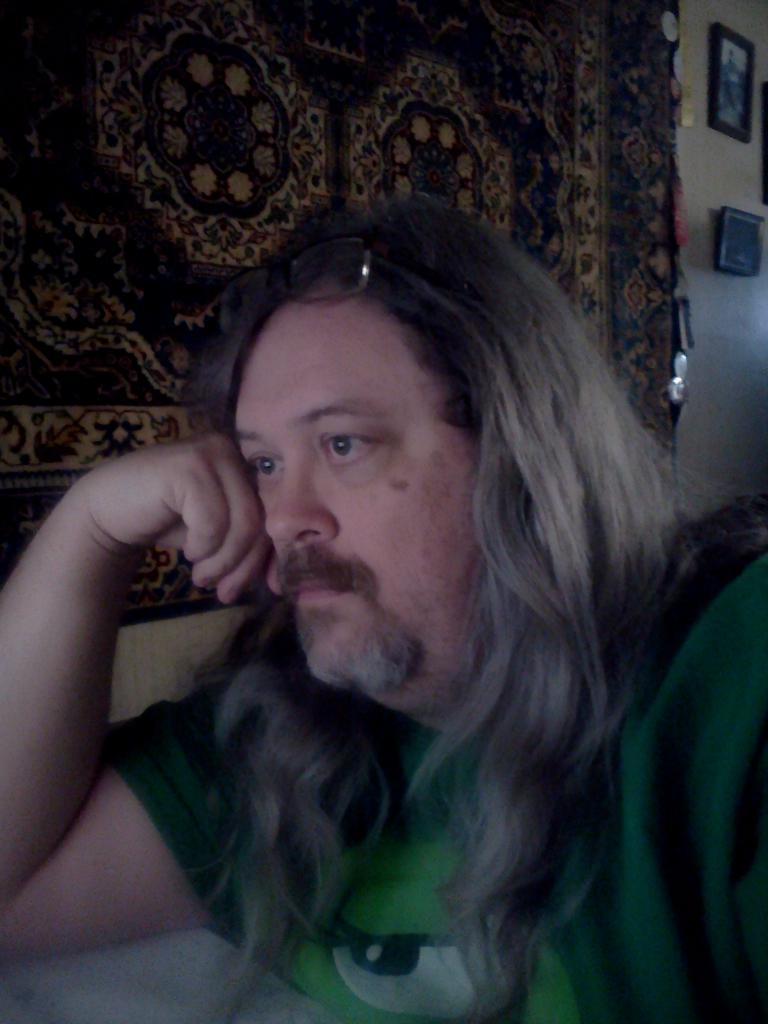Who is present in the image? There is a man in the image. Where is the man located in the image? The man is sitting on the right side of the image. What is the man doing with his hand in the image? The man has his hand on the table. What can be seen in the top right side of the image? There are portraits in the top right side of the image. What type of fowl can be seen in the image? There is no fowl present in the image. How many minutes does the man spend sitting in the image? The image does not provide information about the duration of time the man spends sitting, so it cannot be determined from the image. 